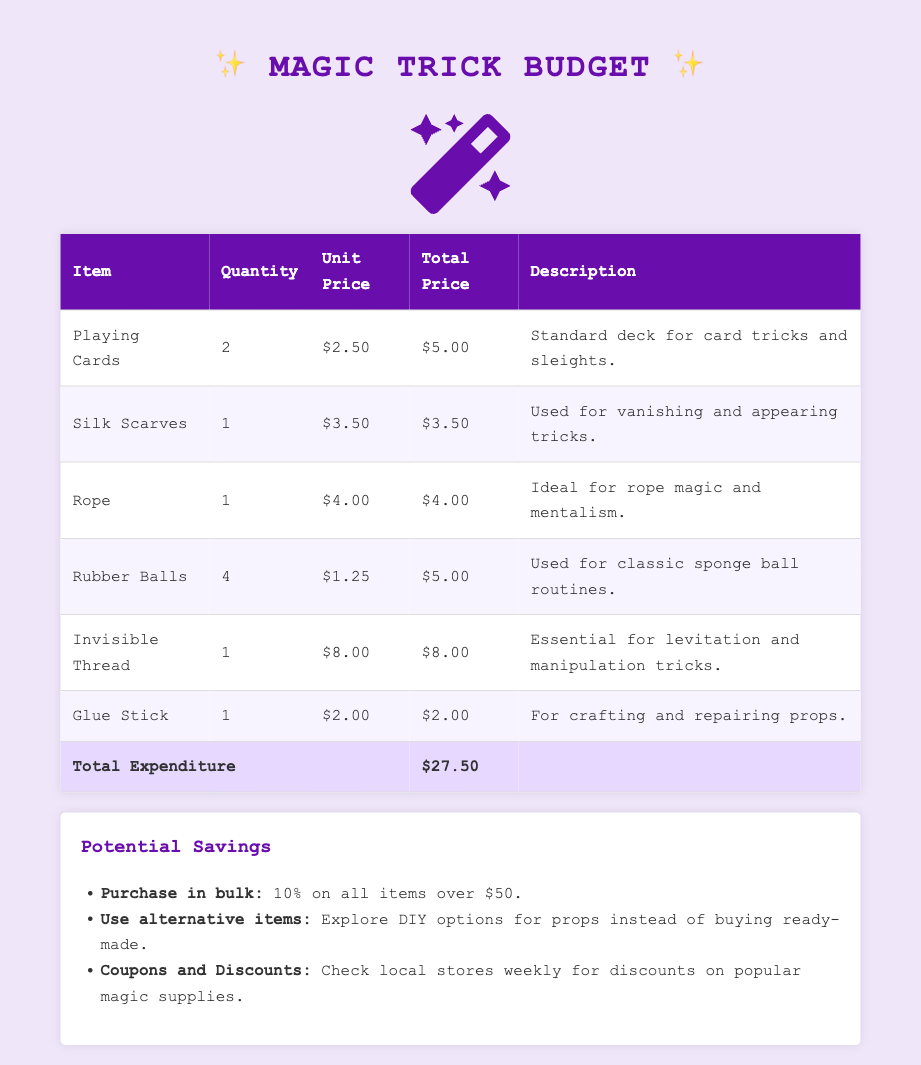What is the total expenditure? The total expenditure is calculated by adding the total prices of all items listed, which equals $27.50.
Answer: $27.50 How many rubber balls were purchased? The document states that 4 rubber balls were purchased for magic routines.
Answer: 4 What is the unit price of the invisible thread? The unit price for the invisible thread as listed in the document is $8.00.
Answer: $8.00 Which item is used for crafting and repairing props? According to the document, the glue stick is used for crafting and repairing props.
Answer: Glue Stick What potential savings could be gained by purchasing in bulk? The document suggests purchasing in bulk can yield a 10% savings on all items over $50.
Answer: 10% What type of tricks can be performed with silk scarves? The silk scarves are used for vanishing and appearing tricks as mentioned in the document.
Answer: Vanishing and appearing tricks What is the total quantity of playing cards listed? The document indicates that 2 packs of playing cards are listed under the quantities purchased.
Answer: 2 What alternative option is suggested for magic props? The document recommends exploring DIY options for props instead of buying ready-made ones.
Answer: DIY options What color is used for the total expenditure cell? The total expenditure cell is highlighted in a distinct color, which is light purple as described in the styling.
Answer: Light purple 